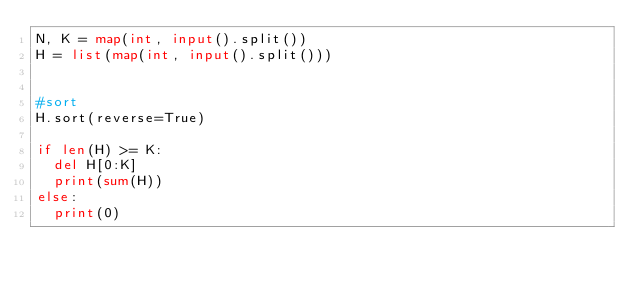Convert code to text. <code><loc_0><loc_0><loc_500><loc_500><_Python_>N, K = map(int, input().split())
H = list(map(int, input().split()))


#sort
H.sort(reverse=True)

if len(H) >= K:
  del H[0:K]
  print(sum(H))
else:
  print(0)
</code> 